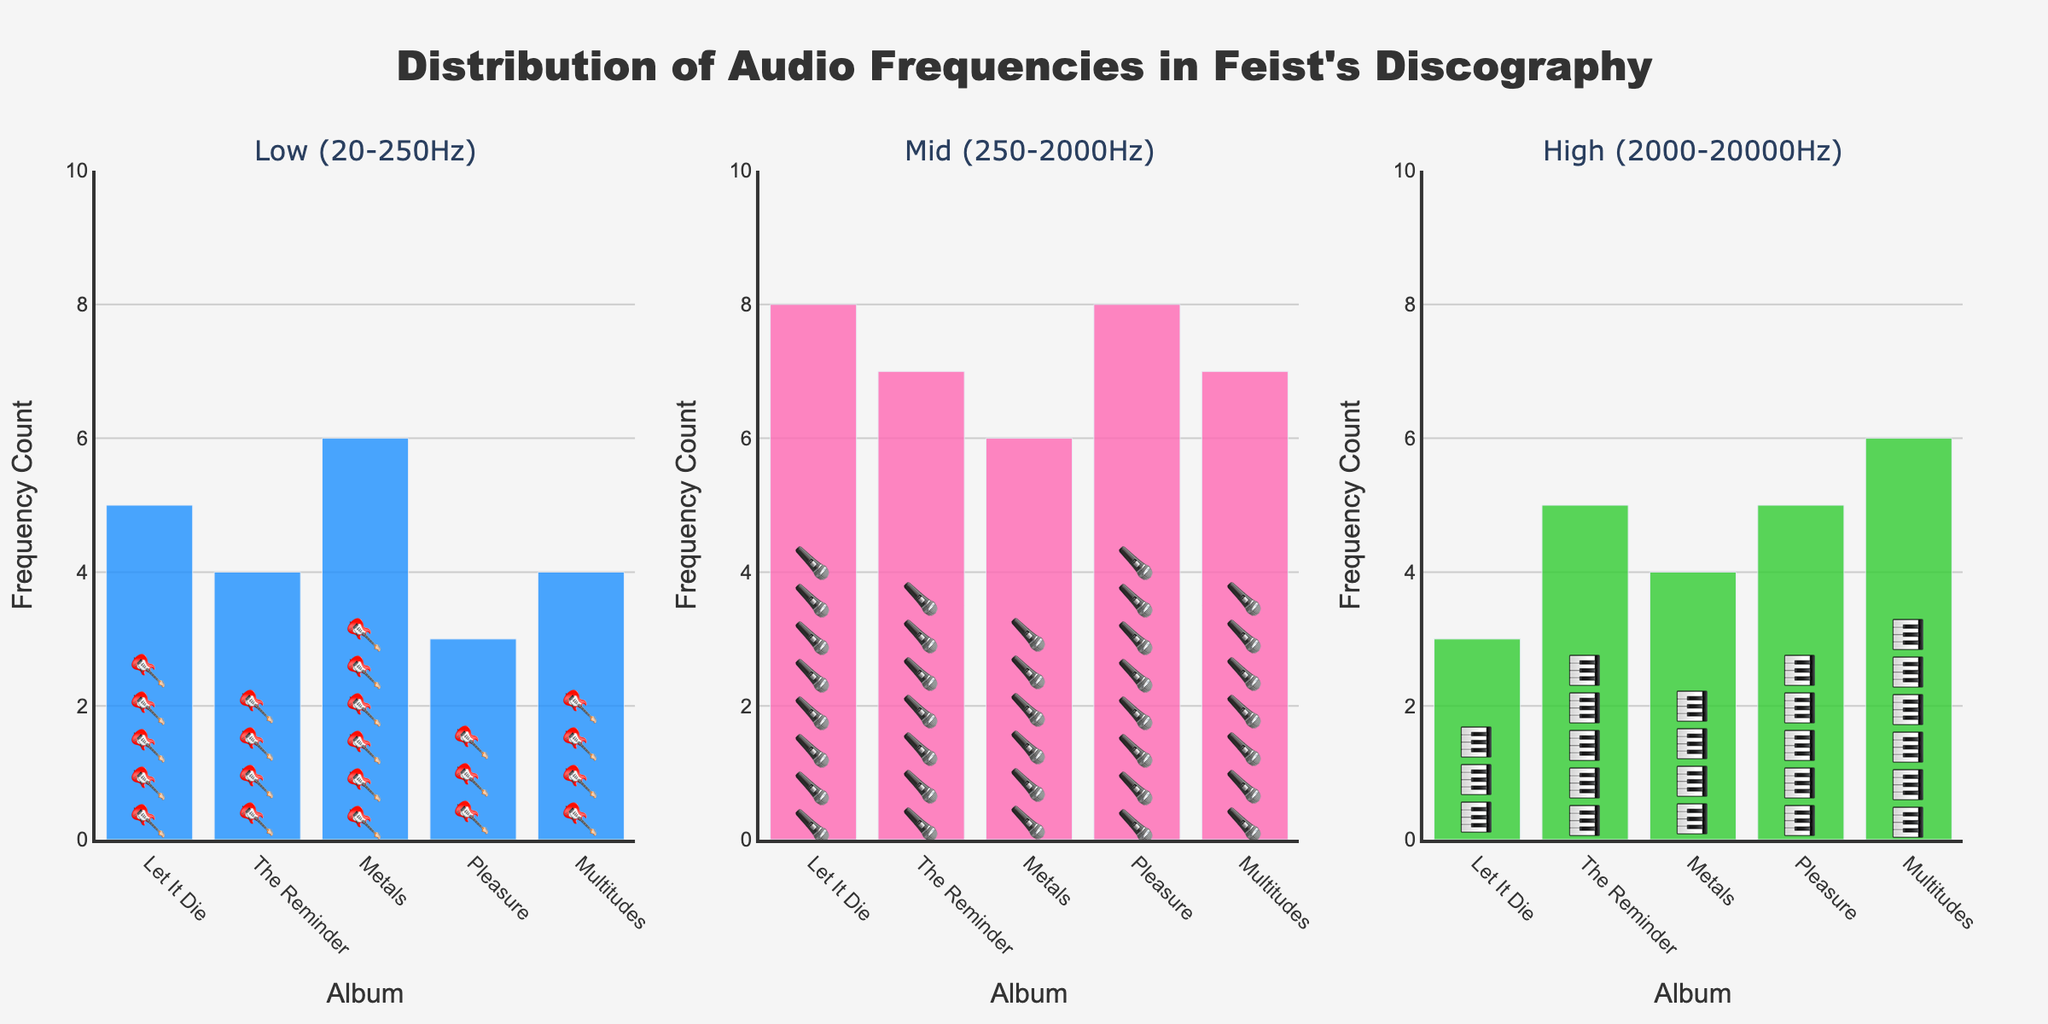What is the title of the figure? The title is located at the top of the figure and provides an overall description of what the figure represents. The title specifically states the subject matter of the data shown. The title of the figure is 'Distribution of Audio Frequencies in Feist's Discography'.
Answer: Distribution of Audio Frequencies in Feist's Discography How many albums are represented in the plot? Each bar in the figures for Low, Mid, and High frequencies represents an album by Feist. There are 5 bars in each subplot, which correspond to the total number of albums.
Answer: 5 Which album has the highest high frequency count? To find the album with the highest high frequency, look at the plot for the High (2000-20000Hz) frequency range. 'Multitudes' has the highest count with a value of 6.
Answer: Multitudes What is the total frequency count for the album 'Let It Die'? Sum the frequency counts for Low, Mid, and High for 'Let It Die'. The values are 5 (Low) + 8 (Mid) + 3 (High). So, the total is 5 + 8 + 3 = 16.
Answer: 16 Which frequency range has the most uniform distribution across all albums? Compare the ranges for uniformity by looking at the bar heights in each subplot. The Mid (250-2000Hz) frequency range shows a relatively stable distribution with counts of 8, 7, 6, 8, and 7.
Answer: Mid (250-2000Hz) What is the difference in the low frequency count between 'Let It Die' and 'Pleasure'? Subtract the low frequency count of 'Pleasure' from the low frequency count of 'Let It Die': 5 (Let It Die) - 3 (Pleasure) = 2.
Answer: 2 Which album shows the highest variation in frequency distribution across Low, Mid, and High ranges? The album with the highest variation has the largest difference between its maximum and minimum frequency counts across Low, Mid, and High. 'Let It Die': range from 3 to 8 (8-3=5). 'The Reminder': range from 4 to 7 (7-4=3). 'Metals': range from 4 to 6 (6-4=2). 'Pleasure': range from 3 to 8 (8-3=5). 'Multitudes' range from 4 to 7 (7-4=3). 'Let It Die' and 'Pleasure' both have a variation of 5.
Answer: Let It Die, Pleasure Which frequency range has the highest average count across all albums? Calculate the average counts for Low, Mid, and High ranges. Low: (5+4+6+3+4)/5 = 22/5 = 4.4; Mid: (8+7+6+8+7)/5 = 36/5 = 7.2; High: (3+5+4+5+6)/5 = 23/5 = 4.6. The Mid range has the highest average count.
Answer: Mid (250-2000Hz) For which album is the difference between Mid and High frequency counts the greatest? Calculate the difference between Mid and High frequency counts for each album. 'Let It Die': 8-3=5; 'The Reminder': 7-5=2; 'Metals': 6-4=2; 'Pleasure': 8-5=3; 'Multitudes': 7-6=1. 'Let It Die' has the greatest difference.
Answer: Let It Die 